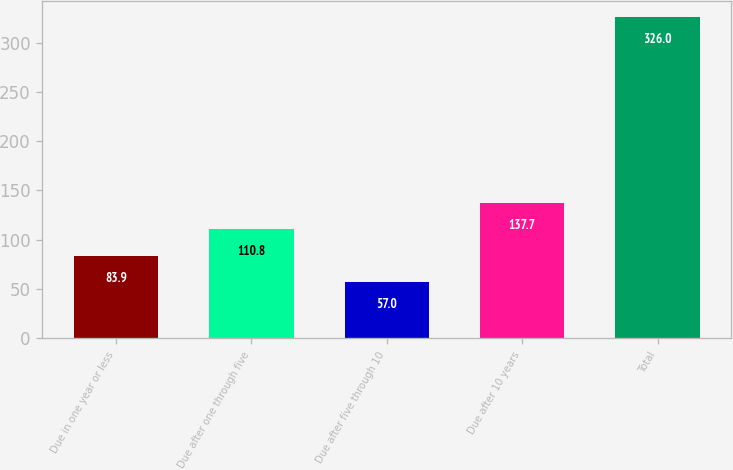Convert chart to OTSL. <chart><loc_0><loc_0><loc_500><loc_500><bar_chart><fcel>Due in one year or less<fcel>Due after one through five<fcel>Due after five through 10<fcel>Due after 10 years<fcel>Total<nl><fcel>83.9<fcel>110.8<fcel>57<fcel>137.7<fcel>326<nl></chart> 